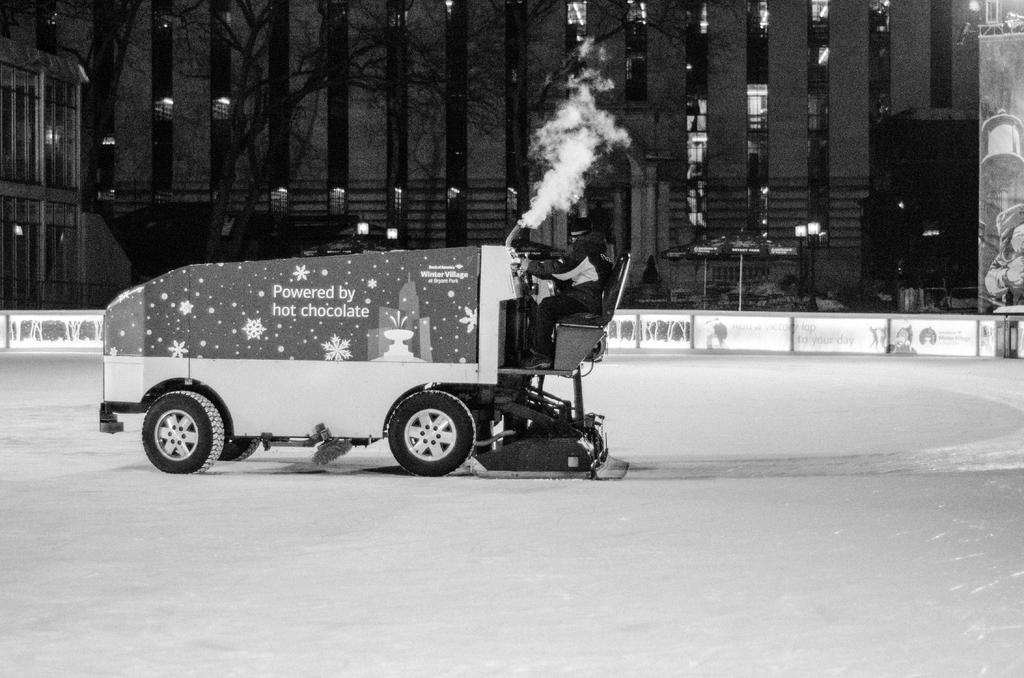What is the person in the image doing? The person is riding a vehicle in the image. What can be seen on the vehicle? There is text written on the vehicle. What is visible in the background behind the vehicle? Buildings, trees, and poles are present behind the vehicle. What type of attraction can be seen in the aftermath of the camp in the image? There is no attraction, aftermath, or camp present in the image; it features a person riding a vehicle with text on it and a background of buildings, trees, and poles. 